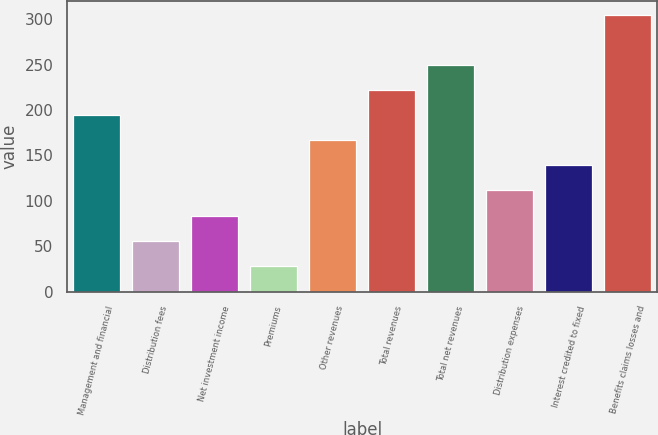<chart> <loc_0><loc_0><loc_500><loc_500><bar_chart><fcel>Management and financial<fcel>Distribution fees<fcel>Net investment income<fcel>Premiums<fcel>Other revenues<fcel>Total revenues<fcel>Total net revenues<fcel>Distribution expenses<fcel>Interest credited to fixed<fcel>Benefits claims losses and<nl><fcel>194.2<fcel>56.2<fcel>83.8<fcel>28.6<fcel>166.6<fcel>221.8<fcel>249.4<fcel>111.4<fcel>139<fcel>304.6<nl></chart> 